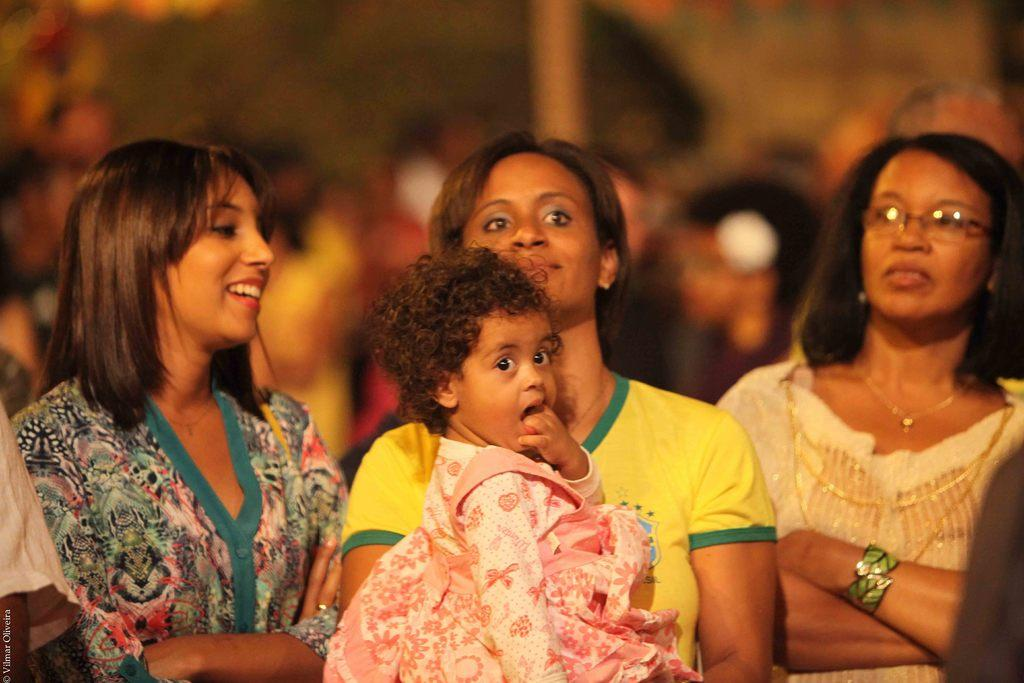How many women are in the image? There are three women in the foreground of the image. What are the women doing in the image? One of the women is carrying a kid. Can you describe the background of the image? The background of the image is blurred. What type of fish can be seen swimming in the background of the image? There are no fish present in the image; the background is blurred. What experience do the women have in the image? The facts provided do not give any information about the women's experiences, so it cannot be determined from the image. 